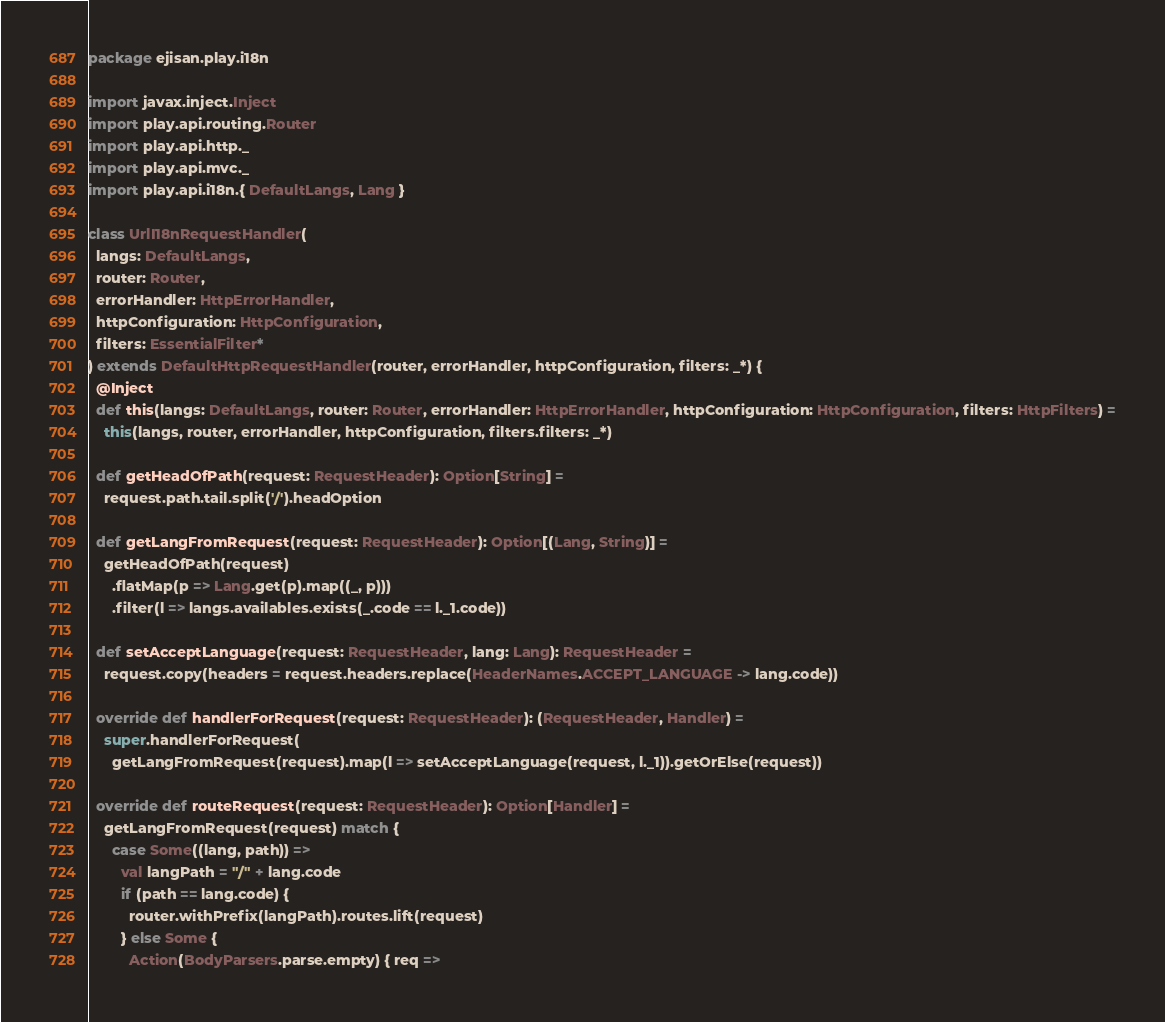Convert code to text. <code><loc_0><loc_0><loc_500><loc_500><_Scala_>package ejisan.play.i18n

import javax.inject.Inject
import play.api.routing.Router
import play.api.http._
import play.api.mvc._
import play.api.i18n.{ DefaultLangs, Lang }

class UrlI18nRequestHandler(
  langs: DefaultLangs,
  router: Router,
  errorHandler: HttpErrorHandler,
  httpConfiguration: HttpConfiguration,
  filters: EssentialFilter*
) extends DefaultHttpRequestHandler(router, errorHandler, httpConfiguration, filters: _*) {
  @Inject
  def this(langs: DefaultLangs, router: Router, errorHandler: HttpErrorHandler, httpConfiguration: HttpConfiguration, filters: HttpFilters) =
    this(langs, router, errorHandler, httpConfiguration, filters.filters: _*)

  def getHeadOfPath(request: RequestHeader): Option[String] =
    request.path.tail.split('/').headOption

  def getLangFromRequest(request: RequestHeader): Option[(Lang, String)] =
    getHeadOfPath(request)
      .flatMap(p => Lang.get(p).map((_, p)))
      .filter(l => langs.availables.exists(_.code == l._1.code))

  def setAcceptLanguage(request: RequestHeader, lang: Lang): RequestHeader =
    request.copy(headers = request.headers.replace(HeaderNames.ACCEPT_LANGUAGE -> lang.code))

  override def handlerForRequest(request: RequestHeader): (RequestHeader, Handler) =
    super.handlerForRequest(
      getLangFromRequest(request).map(l => setAcceptLanguage(request, l._1)).getOrElse(request))

  override def routeRequest(request: RequestHeader): Option[Handler] =
    getLangFromRequest(request) match {
      case Some((lang, path)) =>
        val langPath = "/" + lang.code
        if (path == lang.code) {
          router.withPrefix(langPath).routes.lift(request)
        } else Some {
          Action(BodyParsers.parse.empty) { req =></code> 